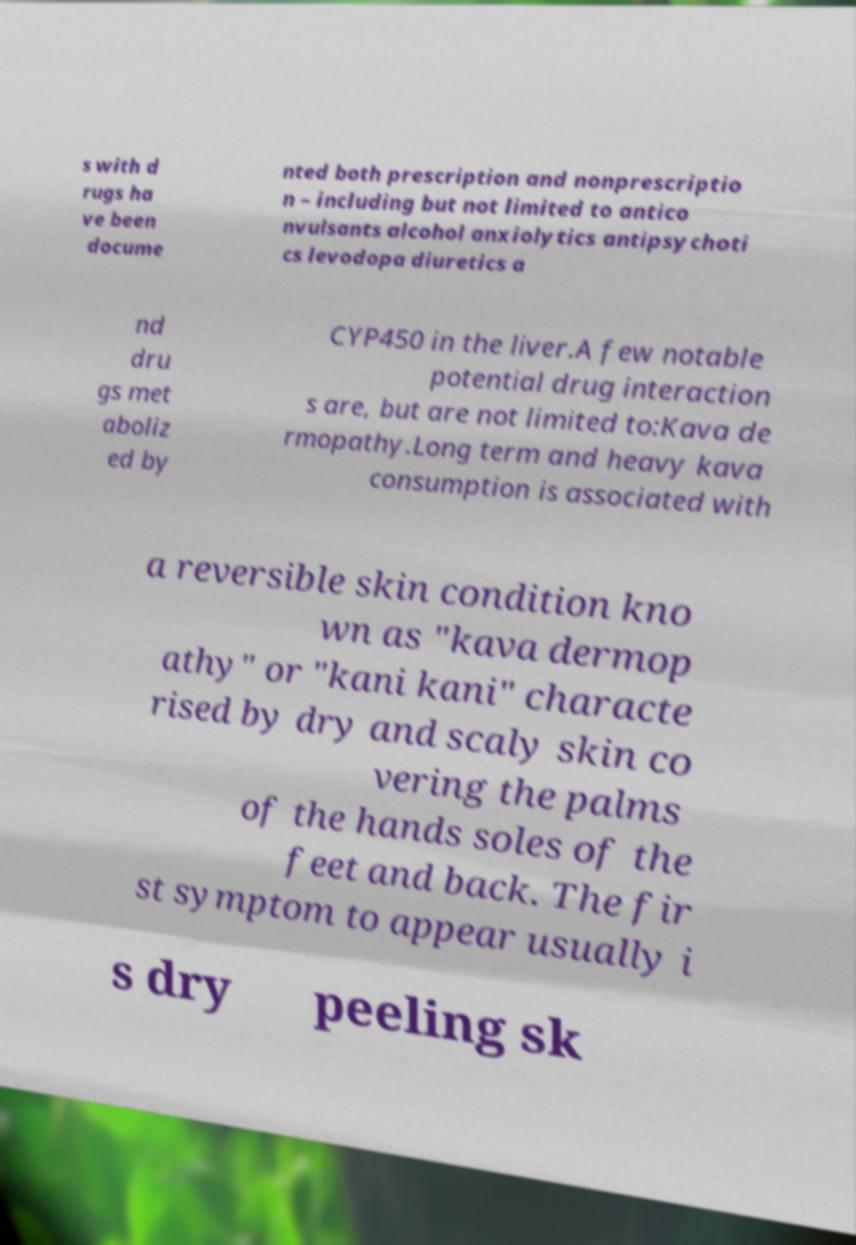I need the written content from this picture converted into text. Can you do that? s with d rugs ha ve been docume nted both prescription and nonprescriptio n – including but not limited to antico nvulsants alcohol anxiolytics antipsychoti cs levodopa diuretics a nd dru gs met aboliz ed by CYP450 in the liver.A few notable potential drug interaction s are, but are not limited to:Kava de rmopathy.Long term and heavy kava consumption is associated with a reversible skin condition kno wn as "kava dermop athy" or "kani kani" characte rised by dry and scaly skin co vering the palms of the hands soles of the feet and back. The fir st symptom to appear usually i s dry peeling sk 